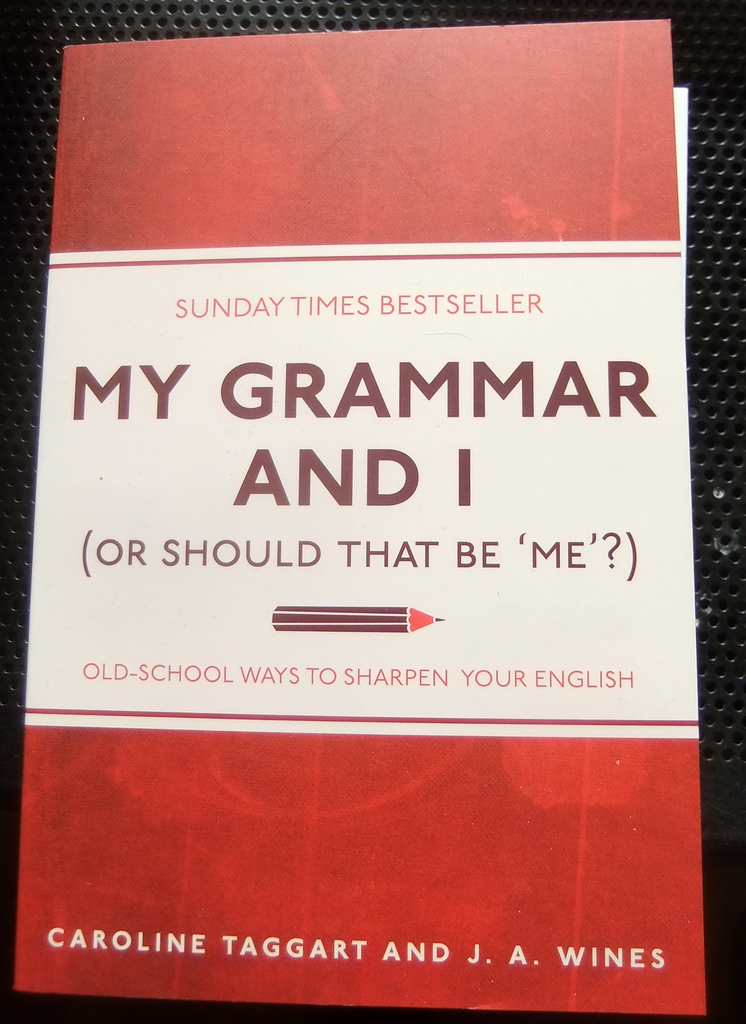Could the title itself pose a grammatical query to engage the reader? Indeed, the title 'My Grammar and I (Or Should That Be 'Me'?)' cleverly introduces a common grammatical conundrum regarding the correct use of pronouns in compound subjects and objects, directly engaging the reader by implicating them in a classic grammar dilemma. This strategy not only draws attention but also sets the stage for the kind of practical grammar advice the reader can expect to find within the book, making it a practical as well as an engaging cover design choice. 